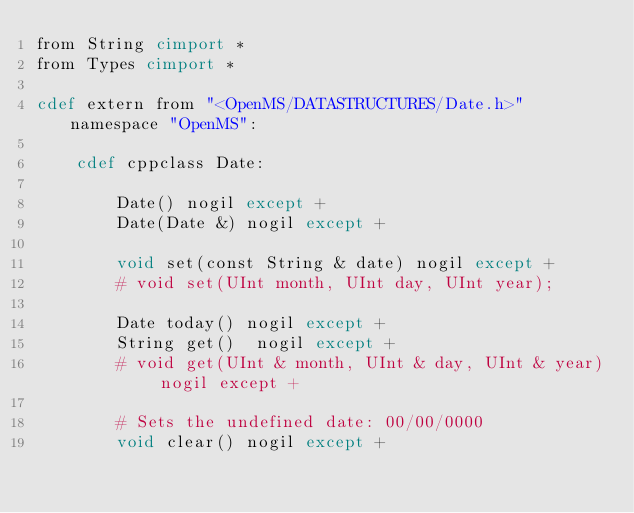<code> <loc_0><loc_0><loc_500><loc_500><_Cython_>from String cimport *
from Types cimport *

cdef extern from "<OpenMS/DATASTRUCTURES/Date.h>" namespace "OpenMS":

    cdef cppclass Date:

        Date() nogil except +
        Date(Date &) nogil except +

        void set(const String & date) nogil except +
        # void set(UInt month, UInt day, UInt year);

        Date today() nogil except +
        String get()  nogil except +
        # void get(UInt & month, UInt & day, UInt & year) nogil except +

        # Sets the undefined date: 00/00/0000
        void clear() nogil except +
</code> 